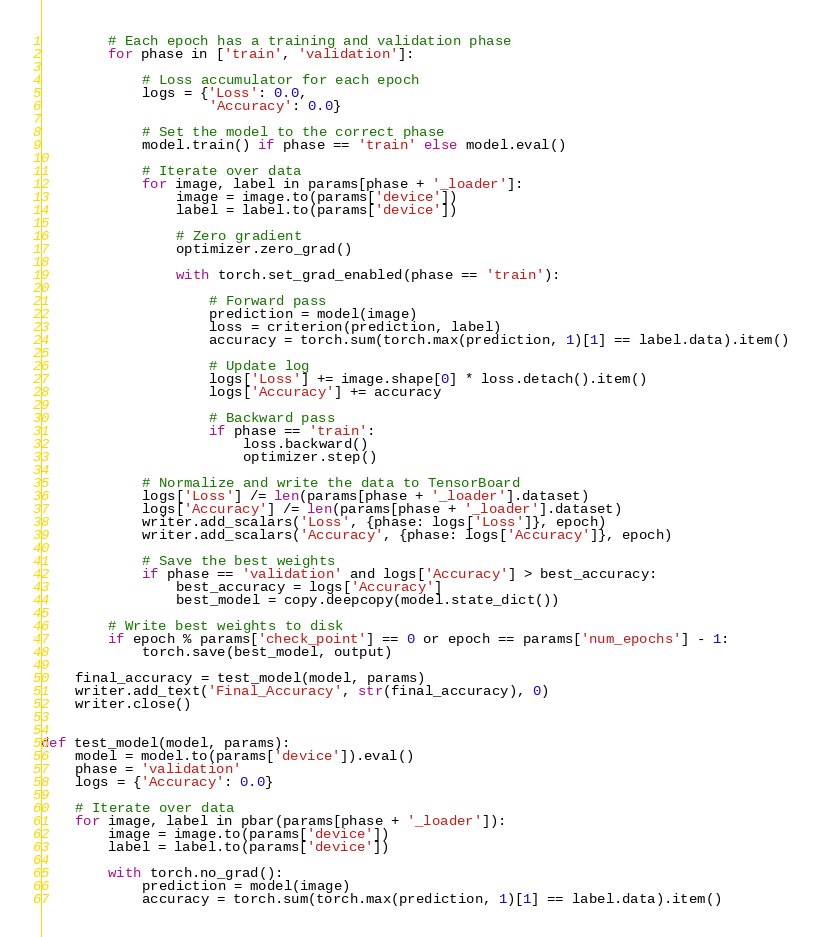<code> <loc_0><loc_0><loc_500><loc_500><_Python_>        # Each epoch has a training and validation phase
        for phase in ['train', 'validation']:

            # Loss accumulator for each epoch
            logs = {'Loss': 0.0,
                    'Accuracy': 0.0}

            # Set the model to the correct phase
            model.train() if phase == 'train' else model.eval()

            # Iterate over data
            for image, label in params[phase + '_loader']:
                image = image.to(params['device'])
                label = label.to(params['device'])

                # Zero gradient
                optimizer.zero_grad()

                with torch.set_grad_enabled(phase == 'train'):

                    # Forward pass
                    prediction = model(image)
                    loss = criterion(prediction, label)
                    accuracy = torch.sum(torch.max(prediction, 1)[1] == label.data).item()

                    # Update log
                    logs['Loss'] += image.shape[0] * loss.detach().item()
                    logs['Accuracy'] += accuracy

                    # Backward pass
                    if phase == 'train':
                        loss.backward()
                        optimizer.step()

            # Normalize and write the data to TensorBoard
            logs['Loss'] /= len(params[phase + '_loader'].dataset)
            logs['Accuracy'] /= len(params[phase + '_loader'].dataset)
            writer.add_scalars('Loss', {phase: logs['Loss']}, epoch)
            writer.add_scalars('Accuracy', {phase: logs['Accuracy']}, epoch)

            # Save the best weights
            if phase == 'validation' and logs['Accuracy'] > best_accuracy:
                best_accuracy = logs['Accuracy']
                best_model = copy.deepcopy(model.state_dict())

        # Write best weights to disk
        if epoch % params['check_point'] == 0 or epoch == params['num_epochs'] - 1:
            torch.save(best_model, output)

    final_accuracy = test_model(model, params)
    writer.add_text('Final_Accuracy', str(final_accuracy), 0)
    writer.close()


def test_model(model, params):
    model = model.to(params['device']).eval()
    phase = 'validation'
    logs = {'Accuracy': 0.0}

    # Iterate over data
    for image, label in pbar(params[phase + '_loader']):
        image = image.to(params['device'])
        label = label.to(params['device'])

        with torch.no_grad():
            prediction = model(image)
            accuracy = torch.sum(torch.max(prediction, 1)[1] == label.data).item()</code> 